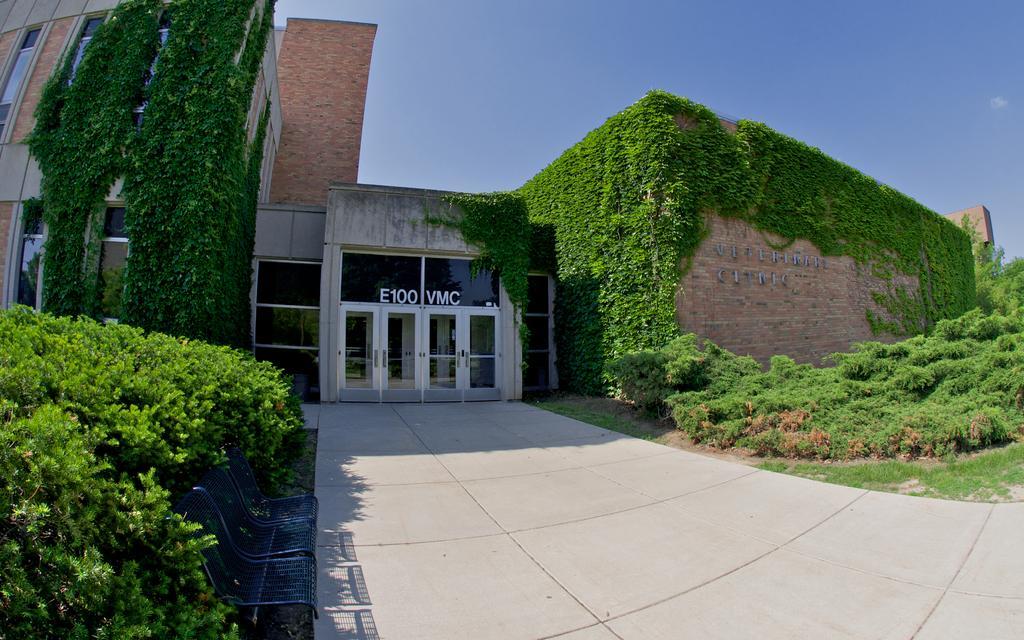Describe this image in one or two sentences. In this image we can see walkway and there are some trees, plants in left and right side of the image and in the background of the image there is building and clear sky. 